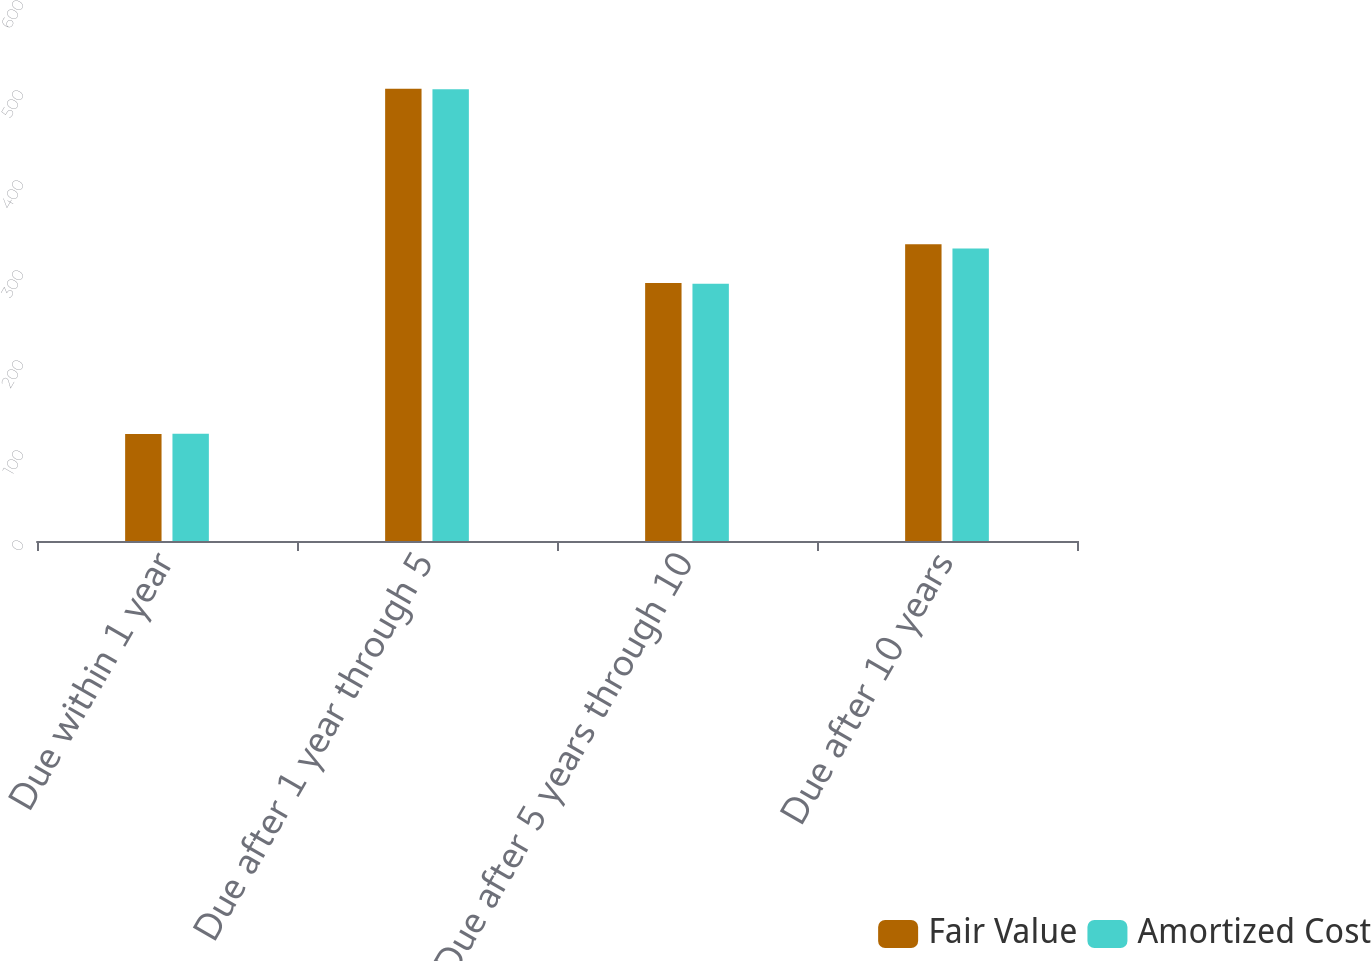Convert chart to OTSL. <chart><loc_0><loc_0><loc_500><loc_500><stacked_bar_chart><ecel><fcel>Due within 1 year<fcel>Due after 1 year through 5<fcel>Due after 5 years through 10<fcel>Due after 10 years<nl><fcel>Fair Value<fcel>118.9<fcel>502.6<fcel>286.7<fcel>329.7<nl><fcel>Amortized Cost<fcel>119.1<fcel>502<fcel>285.8<fcel>324.9<nl></chart> 